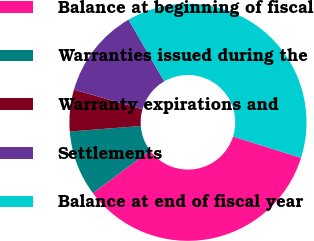Convert chart to OTSL. <chart><loc_0><loc_0><loc_500><loc_500><pie_chart><fcel>Balance at beginning of fiscal<fcel>Warranties issued during the<fcel>Warranty expirations and<fcel>Settlements<fcel>Balance at end of fiscal year<nl><fcel>34.96%<fcel>8.94%<fcel>5.69%<fcel>12.2%<fcel>38.21%<nl></chart> 